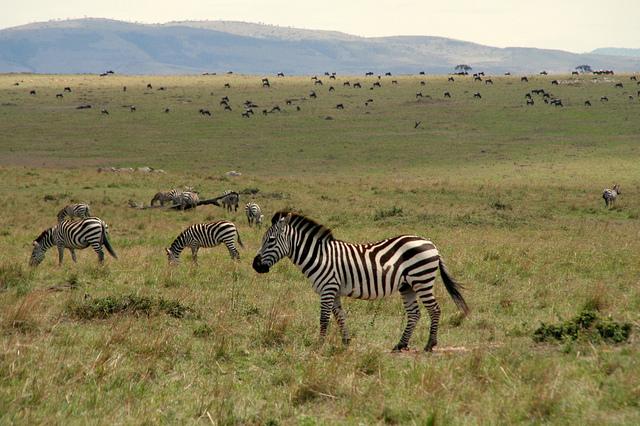What is the vegetation like?
Be succinct. Grassy. Are the zebras on green grass?
Write a very short answer. Yes. Are there zebras in a zoo?
Short answer required. No. How many animals are in the picture?
Quick response, please. 50. Is the terrain flat?
Short answer required. Yes. How many zebra?
Answer briefly. 8. What are the colors of the zebras?
Write a very short answer. Black and white. Are there ferocious animals in the area where this image was taken?
Keep it brief. No. 